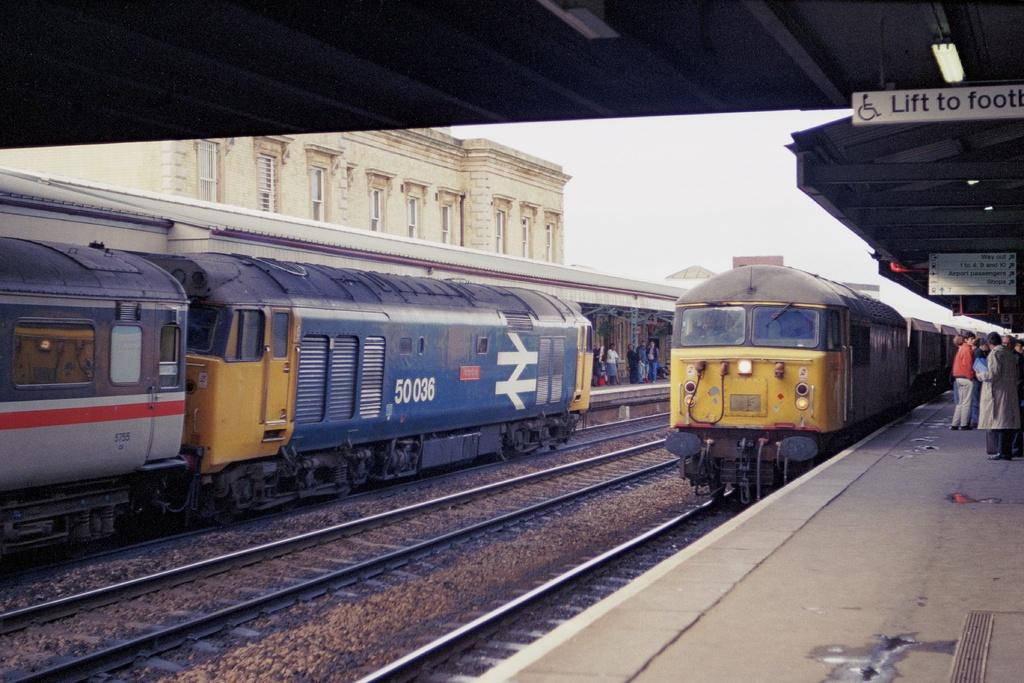What is the train number seen here?
Make the answer very short. 50036. What is the first word mentioned on the sign to the right?
Ensure brevity in your answer.  Lift. 